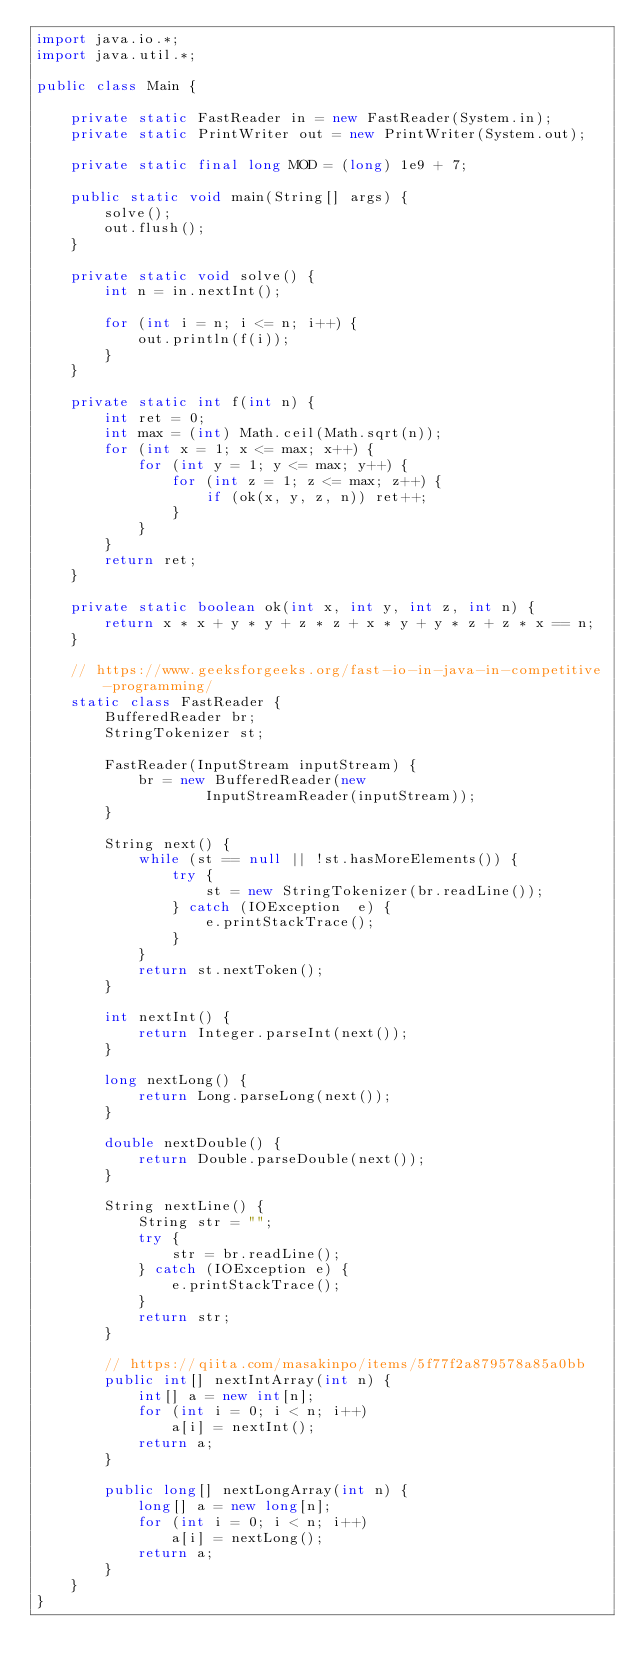<code> <loc_0><loc_0><loc_500><loc_500><_Java_>import java.io.*;
import java.util.*;

public class Main {

    private static FastReader in = new FastReader(System.in);
    private static PrintWriter out = new PrintWriter(System.out);

    private static final long MOD = (long) 1e9 + 7;

    public static void main(String[] args) {
        solve();
        out.flush();
    }

    private static void solve() {
        int n = in.nextInt();

        for (int i = n; i <= n; i++) {
            out.println(f(i));
        }
    }

    private static int f(int n) {
        int ret = 0;
        int max = (int) Math.ceil(Math.sqrt(n));
        for (int x = 1; x <= max; x++) {
            for (int y = 1; y <= max; y++) {
                for (int z = 1; z <= max; z++) {
                    if (ok(x, y, z, n)) ret++;
                }
            }
        }
        return ret;
    }

    private static boolean ok(int x, int y, int z, int n) {
        return x * x + y * y + z * z + x * y + y * z + z * x == n;
    }

    // https://www.geeksforgeeks.org/fast-io-in-java-in-competitive-programming/
    static class FastReader {
        BufferedReader br;
        StringTokenizer st;

        FastReader(InputStream inputStream) {
            br = new BufferedReader(new
                    InputStreamReader(inputStream));
        }

        String next() {
            while (st == null || !st.hasMoreElements()) {
                try {
                    st = new StringTokenizer(br.readLine());
                } catch (IOException  e) {
                    e.printStackTrace();
                }
            }
            return st.nextToken();
        }

        int nextInt() {
            return Integer.parseInt(next());
        }

        long nextLong() {
            return Long.parseLong(next());
        }

        double nextDouble() {
            return Double.parseDouble(next());
        }

        String nextLine() {
            String str = "";
            try {
                str = br.readLine();
            } catch (IOException e) {
                e.printStackTrace();
            }
            return str;
        }

        // https://qiita.com/masakinpo/items/5f77f2a879578a85a0bb
        public int[] nextIntArray(int n) {
            int[] a = new int[n];
            for (int i = 0; i < n; i++)
                a[i] = nextInt();
            return a;
        }

        public long[] nextLongArray(int n) {
            long[] a = new long[n];
            for (int i = 0; i < n; i++)
                a[i] = nextLong();
            return a;
        }
    }
}
</code> 